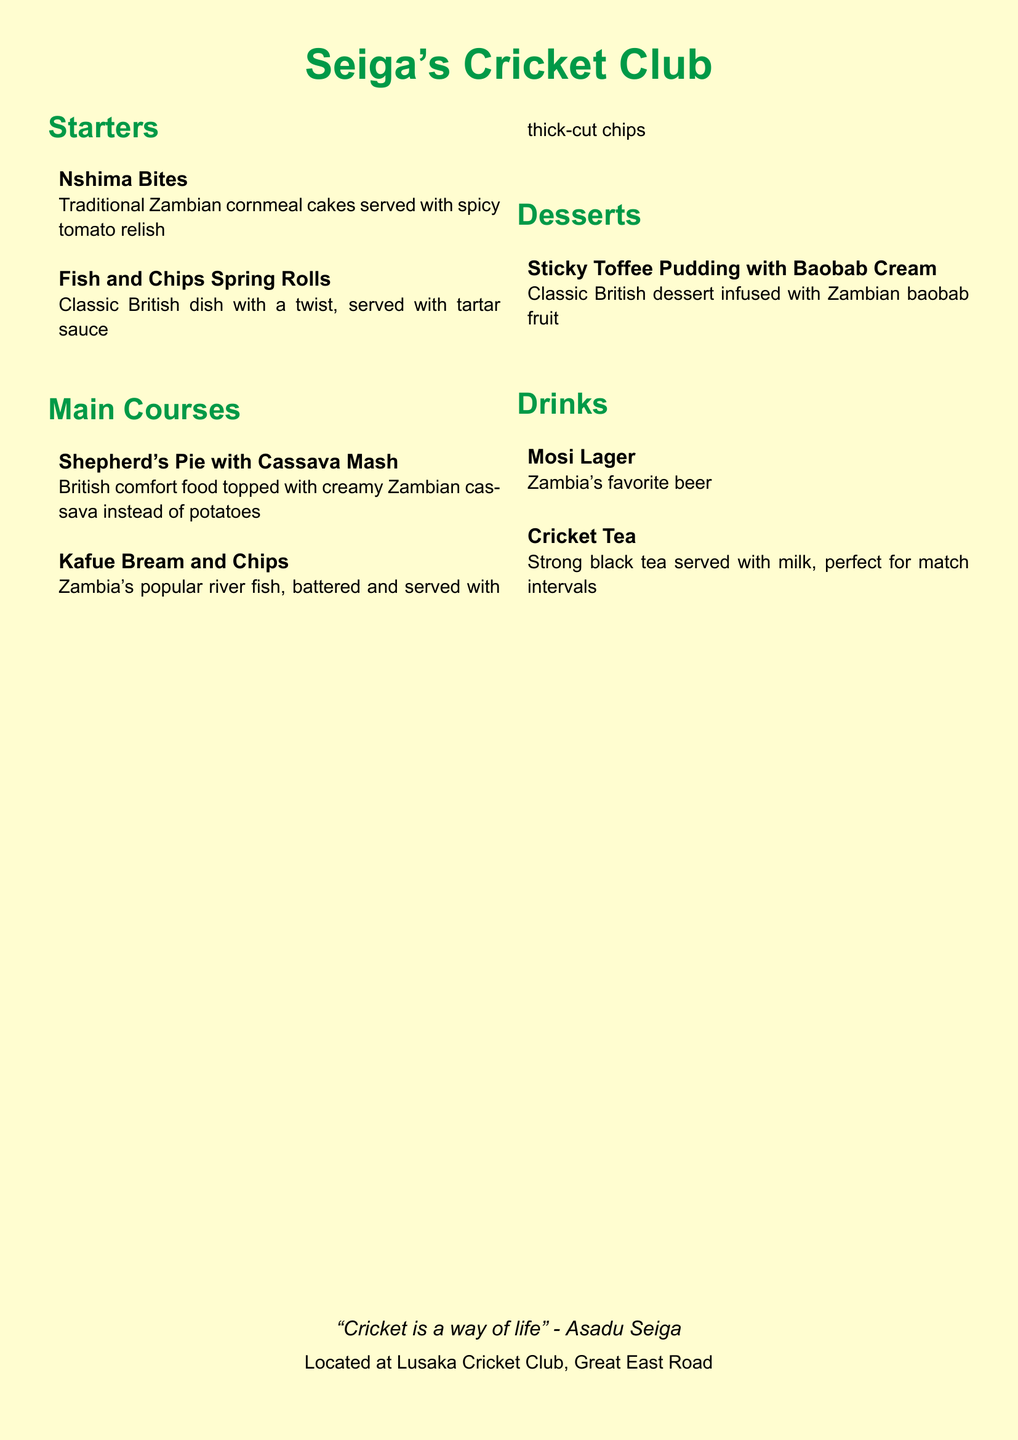What is the name of the restaurant? The title of the restaurant is prominently displayed at the top of the document, which is "Seiga's Cricket Club."
Answer: Seiga's Cricket Club What does "Nshima Bites" come with? The description of "Nshima Bites" states it is served with "spicy tomato relish."
Answer: spicy tomato relish What type of dessert is featured on the menu? The dessert listed in the menu is "Sticky Toffee Pudding with Baobab Cream."
Answer: Sticky Toffee Pudding with Baobab Cream Which drink is described as Zambian's favorite beer? The menu explicitly mentions "Mosi Lager" as Zambia's favorite beer.
Answer: Mosi Lager What is the twist in "Shepherd's Pie" on this menu? The explanation for "Shepherd's Pie" notes it is topped with "creamy Zambian cassava instead of potatoes."
Answer: creamy Zambian cassava instead of potatoes How many sections are there in the menu? The menu contains four distinct sections: Starters, Main Courses, Desserts, and Drinks.
Answer: Four What fish is served with chips? The main course "Kafue Bream and Chips" is a river fish served with chips.
Answer: Kafue Bream Where is the restaurant located? The location of the restaurant is stated at the bottom of the document as "Lusaka Cricket Club, Great East Road."
Answer: Lusaka Cricket Club, Great East Road What is the quote attributed to Asadu Seiga? The menu includes a quote: "Cricket is a way of life."
Answer: Cricket is a way of life 